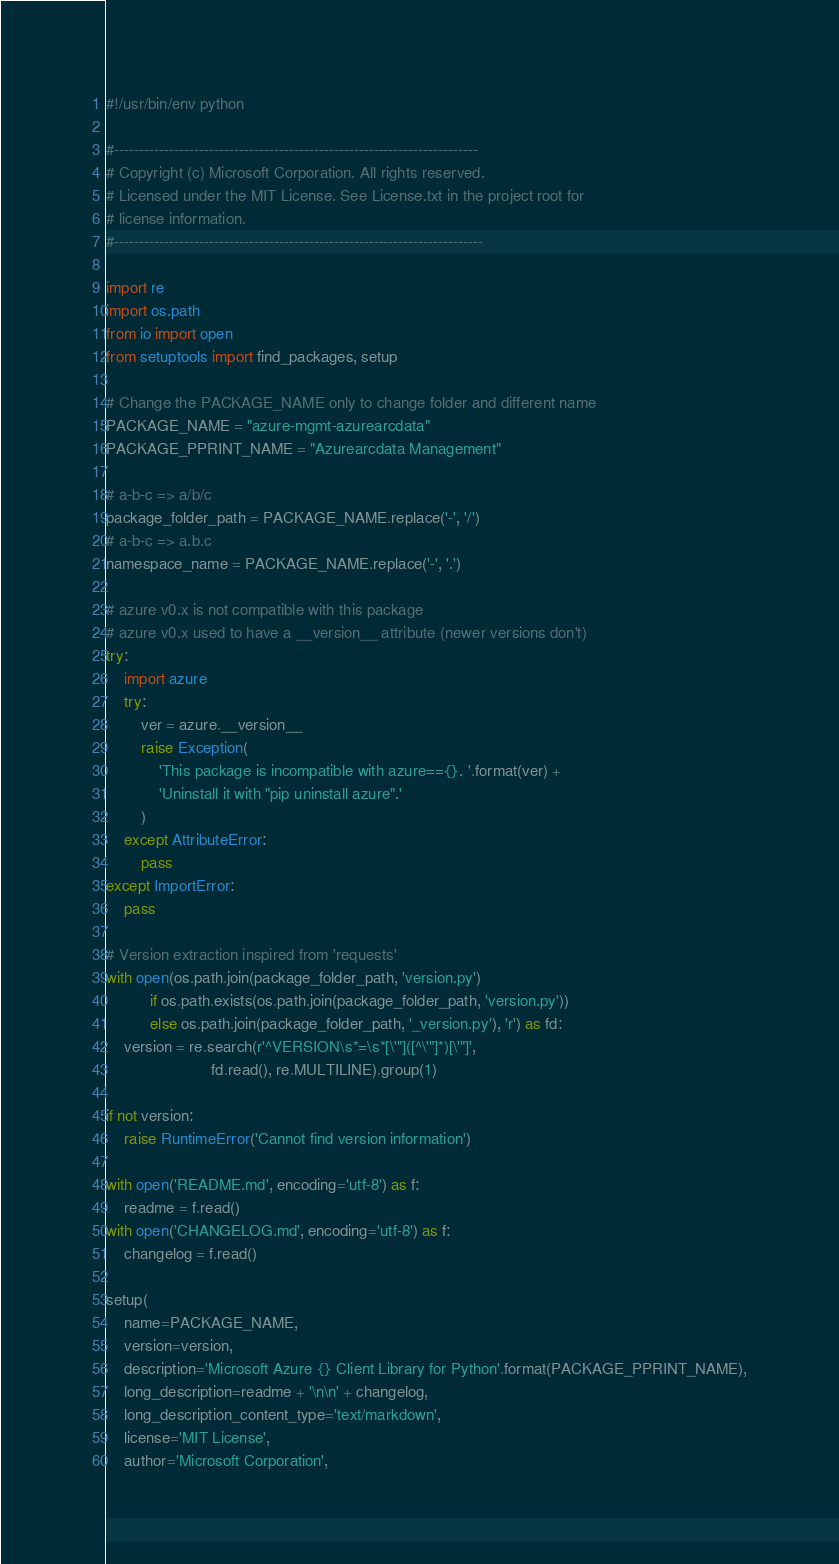<code> <loc_0><loc_0><loc_500><loc_500><_Python_>#!/usr/bin/env python

#-------------------------------------------------------------------------
# Copyright (c) Microsoft Corporation. All rights reserved.
# Licensed under the MIT License. See License.txt in the project root for
# license information.
#--------------------------------------------------------------------------

import re
import os.path
from io import open
from setuptools import find_packages, setup

# Change the PACKAGE_NAME only to change folder and different name
PACKAGE_NAME = "azure-mgmt-azurearcdata"
PACKAGE_PPRINT_NAME = "Azurearcdata Management"

# a-b-c => a/b/c
package_folder_path = PACKAGE_NAME.replace('-', '/')
# a-b-c => a.b.c
namespace_name = PACKAGE_NAME.replace('-', '.')

# azure v0.x is not compatible with this package
# azure v0.x used to have a __version__ attribute (newer versions don't)
try:
    import azure
    try:
        ver = azure.__version__
        raise Exception(
            'This package is incompatible with azure=={}. '.format(ver) +
            'Uninstall it with "pip uninstall azure".'
        )
    except AttributeError:
        pass
except ImportError:
    pass

# Version extraction inspired from 'requests'
with open(os.path.join(package_folder_path, 'version.py')
          if os.path.exists(os.path.join(package_folder_path, 'version.py'))
          else os.path.join(package_folder_path, '_version.py'), 'r') as fd:
    version = re.search(r'^VERSION\s*=\s*[\'"]([^\'"]*)[\'"]',
                        fd.read(), re.MULTILINE).group(1)

if not version:
    raise RuntimeError('Cannot find version information')

with open('README.md', encoding='utf-8') as f:
    readme = f.read()
with open('CHANGELOG.md', encoding='utf-8') as f:
    changelog = f.read()

setup(
    name=PACKAGE_NAME,
    version=version,
    description='Microsoft Azure {} Client Library for Python'.format(PACKAGE_PPRINT_NAME),
    long_description=readme + '\n\n' + changelog,
    long_description_content_type='text/markdown',
    license='MIT License',
    author='Microsoft Corporation',</code> 